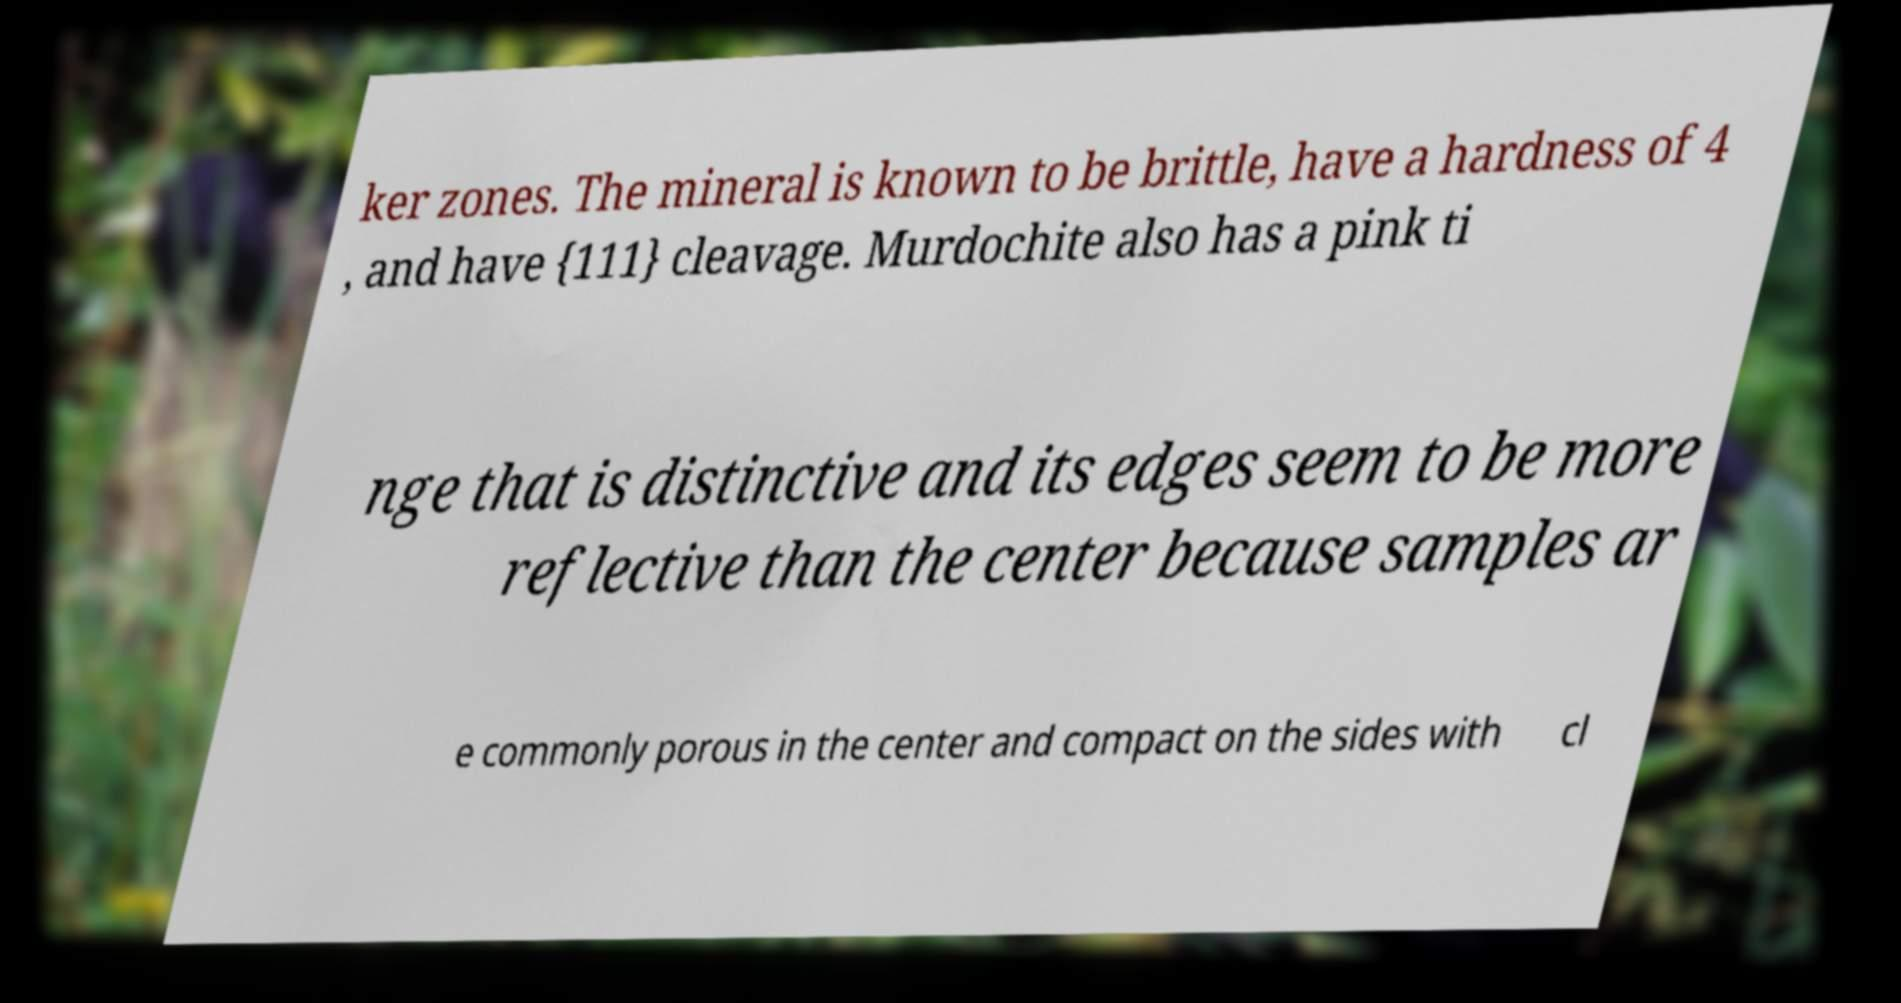Could you assist in decoding the text presented in this image and type it out clearly? ker zones. The mineral is known to be brittle, have a hardness of 4 , and have {111} cleavage. Murdochite also has a pink ti nge that is distinctive and its edges seem to be more reflective than the center because samples ar e commonly porous in the center and compact on the sides with cl 